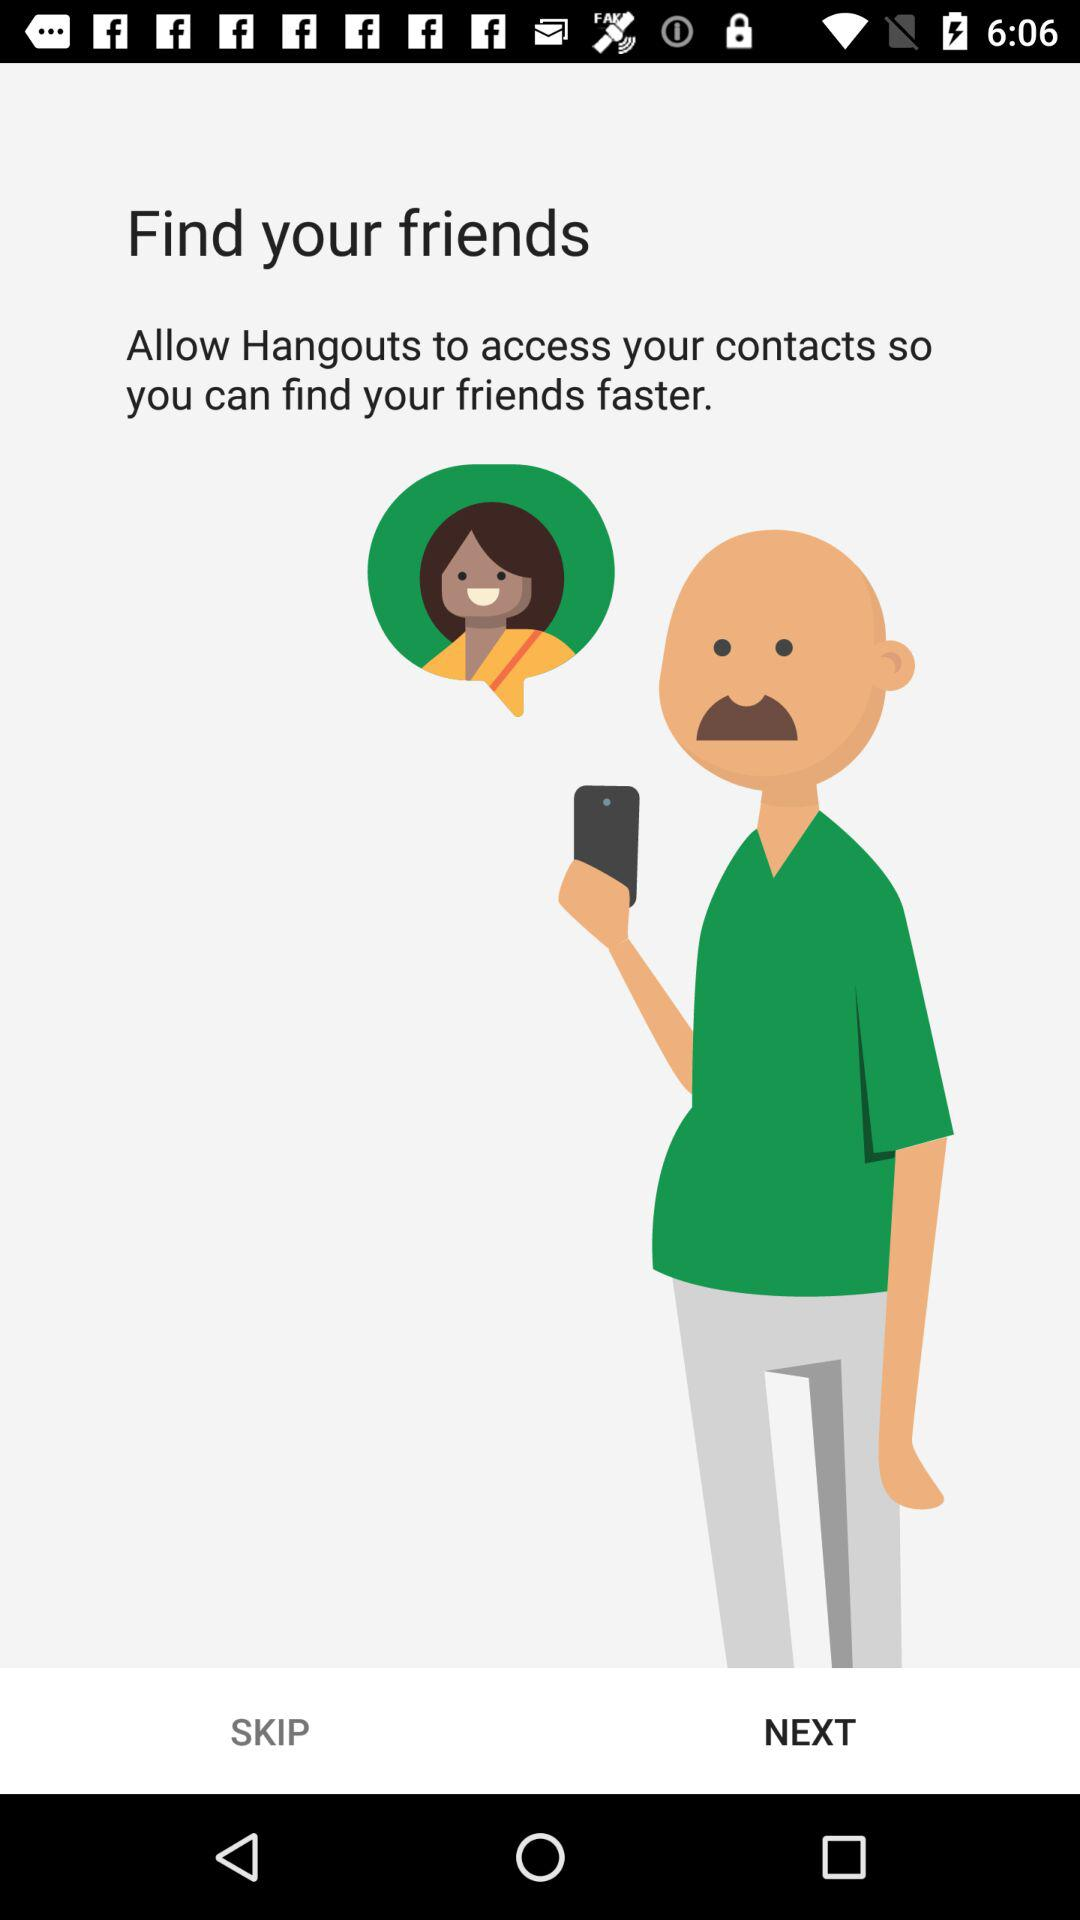How can we find friends? You can find friends by allowing "Hangouts" to access your contacts. 